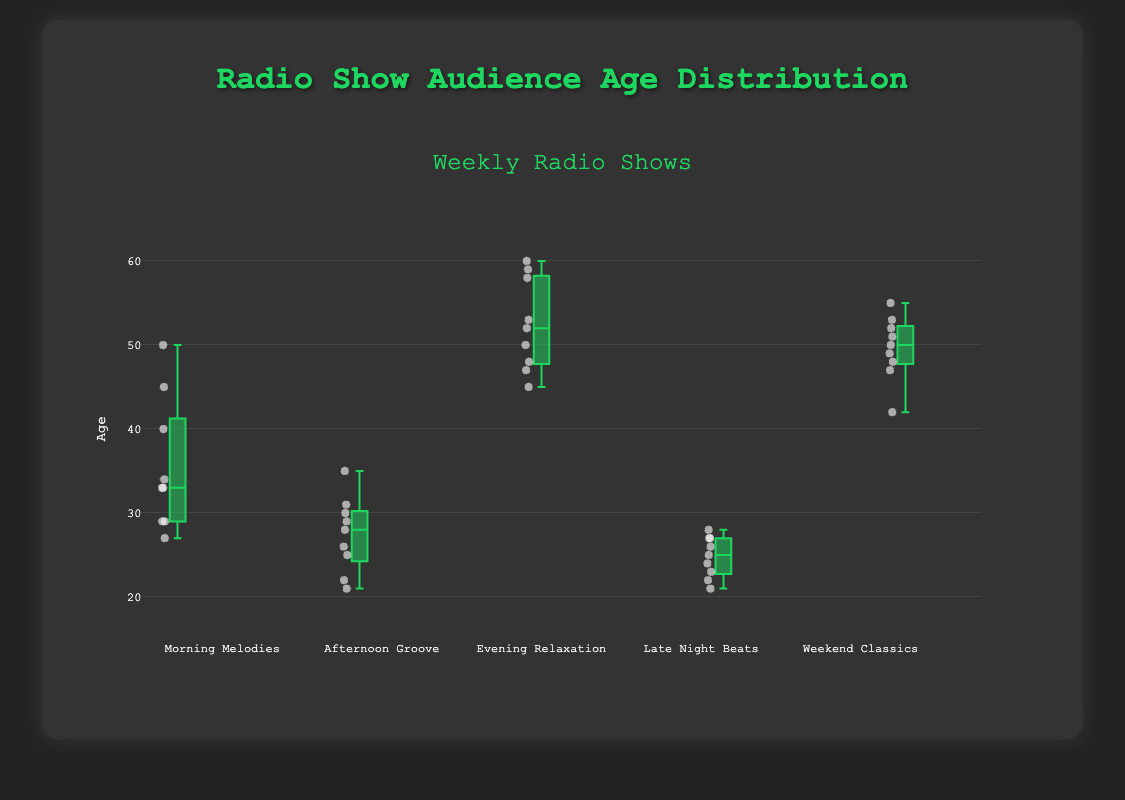What is the median age of the "Morning Melodies" audience? Look at the "Morning Melodies" box plot and identify the line within the box, which represents the median.
Answer: 33 Which radio show has the oldest audience on average? Compare the median values of all shows. The highest median indicates the show with the oldest audience. "Evening Relaxation" has the highest median at around 52.
Answer: Evening Relaxation What is the range of ages for the "Afternoon Groove" audience? The range is the difference between the maximum and minimum ages, indicated by the whiskers of the box plot for "Afternoon Groove". The minimum is 21 and the maximum is 35, so the range is 35 - 21.
Answer: 14 Which show has the most variation in audience ages? Examine the interquartile range (IQR) of each show, indicated by the height of the boxes. "Morning Melodies" and "Evening Relaxation" appear to have large variations, but "Evening Relaxation" has the widest box.
Answer: Evening Relaxation How many age outliers are there in the "Late Night Beats" audience? Outliers are typically shown as individual points outside the whiskers of the box plot. Identify and count any points outside the "Late Night Beats" box and whiskers.
Answer: 0 What is the age of the youngest listener in the "Weekend Classics" audience? The age of the youngest listener is shown at the bottom whisker of the "Weekend Classics" box plot.
Answer: 42 Are there any shows where the median age is above 50? Check the median lines in all box plots. If any median line is above the 50 mark on the y-axis, then its show's median age is above 50. "Evening Relaxation" and "Weekend Classics" have medians above 50.
Answer: Yes Which show has the smallest interquartile range (IQR) of ages? The IQR is the length of the box in the box plot. Look for the shortest box. "Late Night Beats" has the smallest IQR.
Answer: Late Night Beats What is the median age difference between "Morning Melodies" and "Afternoon Groove"? Find the median age of both shows from the box plot ("Morning Melodies" = 33, "Afternoon Groove" = 28) and subtract to get the difference.
Answer: 5 